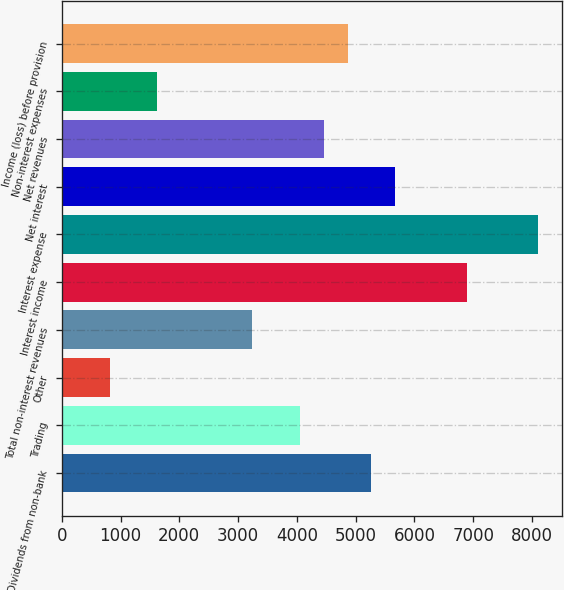Convert chart. <chart><loc_0><loc_0><loc_500><loc_500><bar_chart><fcel>Dividends from non-bank<fcel>Trading<fcel>Other<fcel>Total non-interest revenues<fcel>Interest income<fcel>Interest expense<fcel>Net interest<fcel>Net revenues<fcel>Non-interest expenses<fcel>Income (loss) before provision<nl><fcel>5267.7<fcel>4053<fcel>813.8<fcel>3243.2<fcel>6887.3<fcel>8102<fcel>5672.6<fcel>4457.9<fcel>1623.6<fcel>4862.8<nl></chart> 